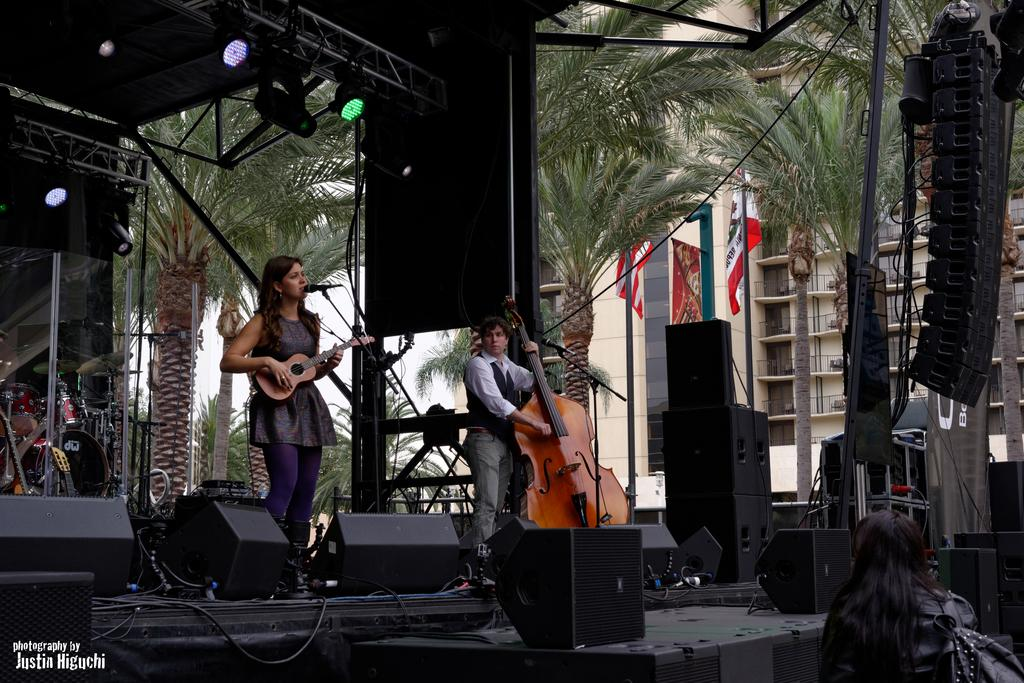How many women are in the image? There are two women in the image. Where are the women located in the image? The women are standing on a stage. What are the women holding in the image? The women are holding guitars. What type of natural elements can be seen in the image? There are trees visible in the image. What man-made structures can be seen in the image? There are flags and buildings in the image. What type of basin is located on the stage in the image? There is no basin present on the stage in the image. How does the neck of the guitar rest on the stage in the image? The neck of the guitar is not resting on the stage in the image; the women are holding the guitars. 